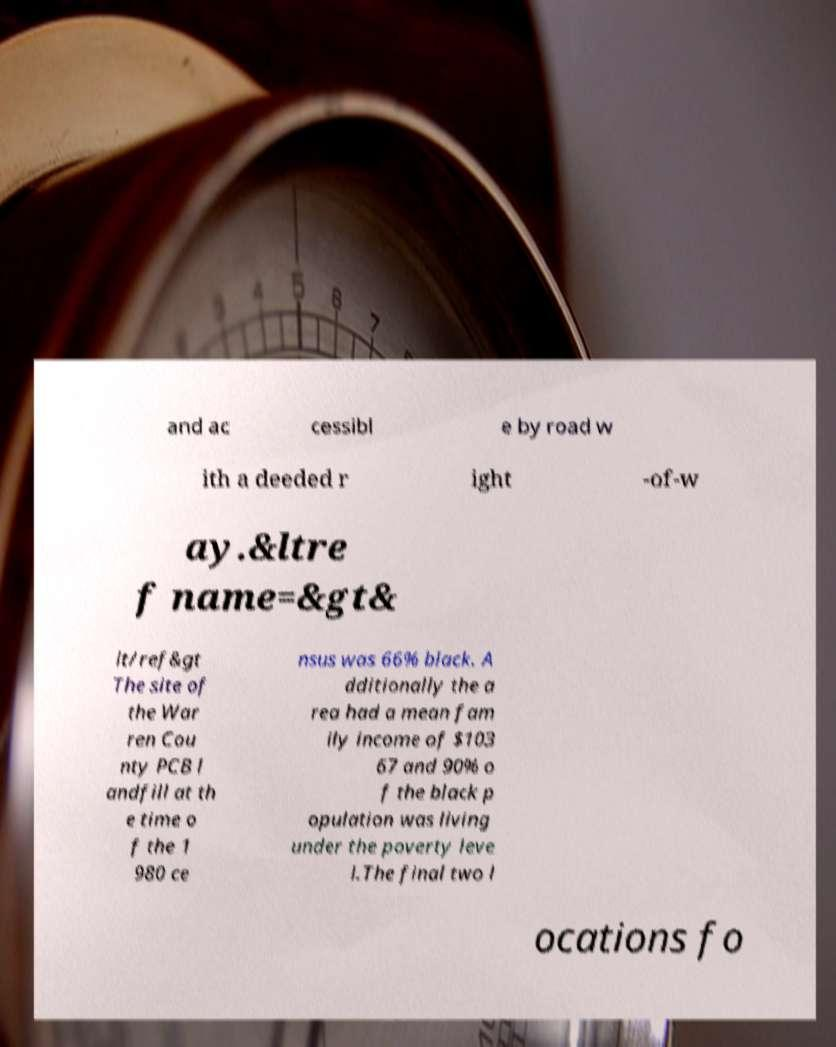Could you assist in decoding the text presented in this image and type it out clearly? and ac cessibl e by road w ith a deeded r ight -of-w ay.&ltre f name=&gt& lt/ref&gt The site of the War ren Cou nty PCB l andfill at th e time o f the 1 980 ce nsus was 66% black. A dditionally the a rea had a mean fam ily income of $103 67 and 90% o f the black p opulation was living under the poverty leve l.The final two l ocations fo 